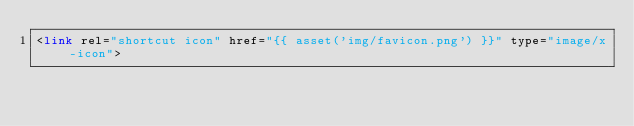Convert code to text. <code><loc_0><loc_0><loc_500><loc_500><_PHP_><link rel="shortcut icon" href="{{ asset('img/favicon.png') }}" type="image/x-icon"></code> 